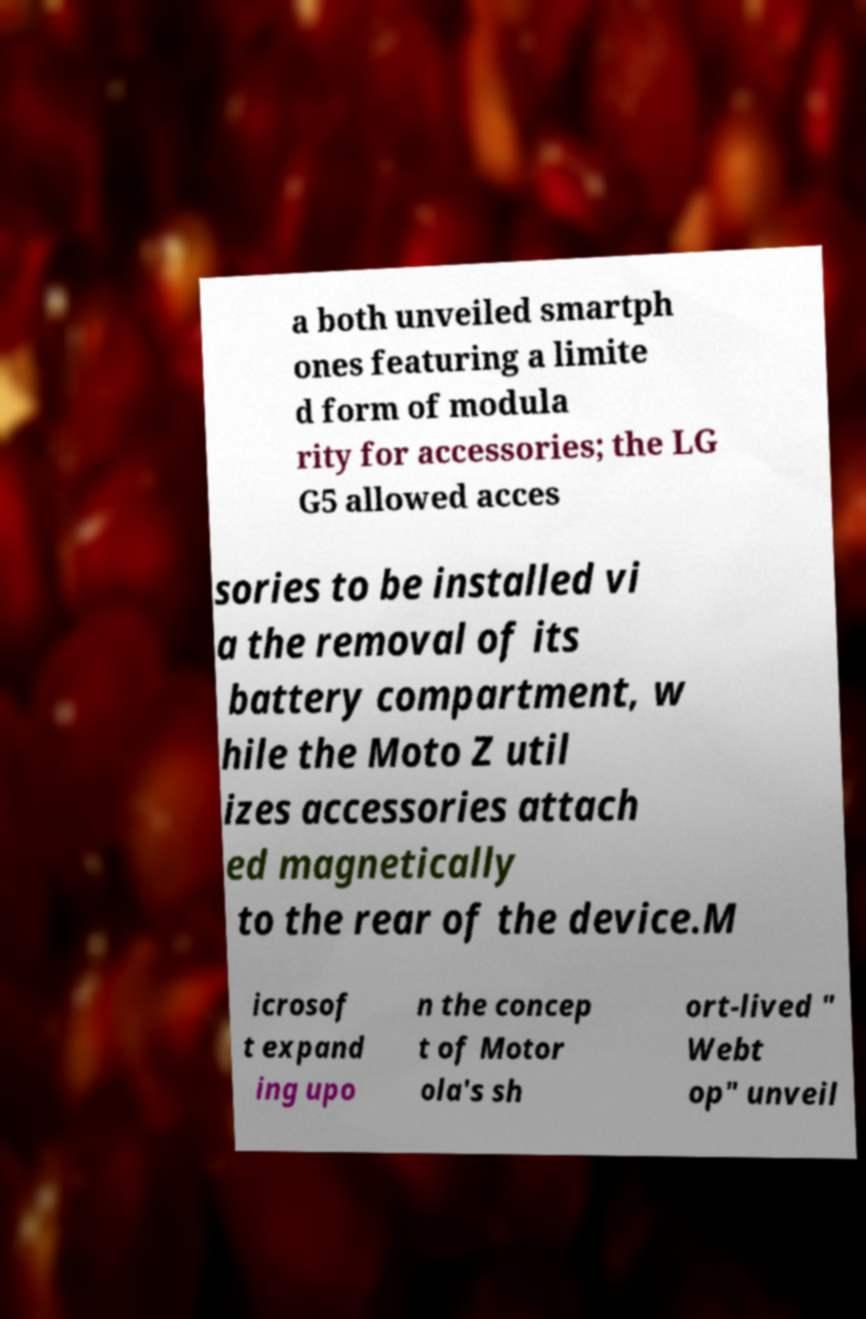What messages or text are displayed in this image? I need them in a readable, typed format. a both unveiled smartph ones featuring a limite d form of modula rity for accessories; the LG G5 allowed acces sories to be installed vi a the removal of its battery compartment, w hile the Moto Z util izes accessories attach ed magnetically to the rear of the device.M icrosof t expand ing upo n the concep t of Motor ola's sh ort-lived " Webt op" unveil 